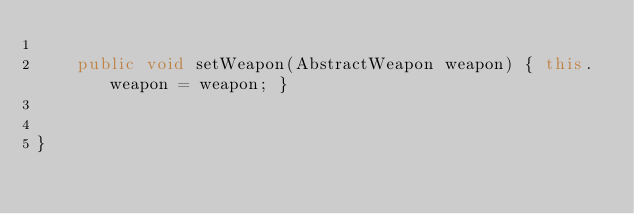<code> <loc_0><loc_0><loc_500><loc_500><_Java_>	
	public void setWeapon(AbstractWeapon weapon) { this.weapon = weapon; }
	
	
}
</code> 